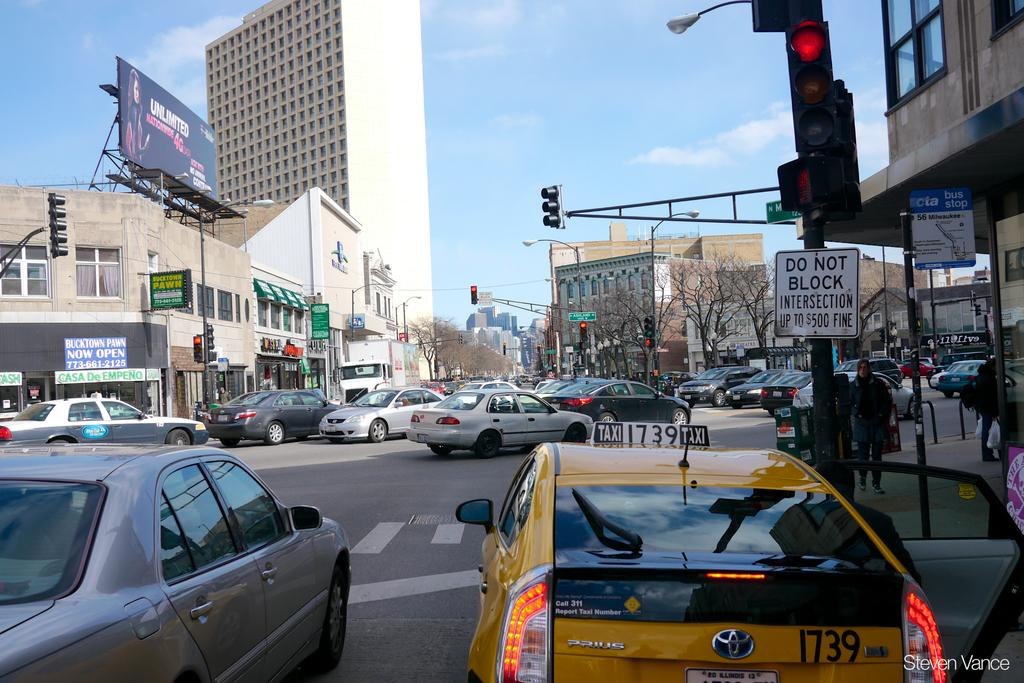<image>
Relay a brief, clear account of the picture shown. A yellow cab is stopped in front of a sign that says Do Not Block Intersection. 